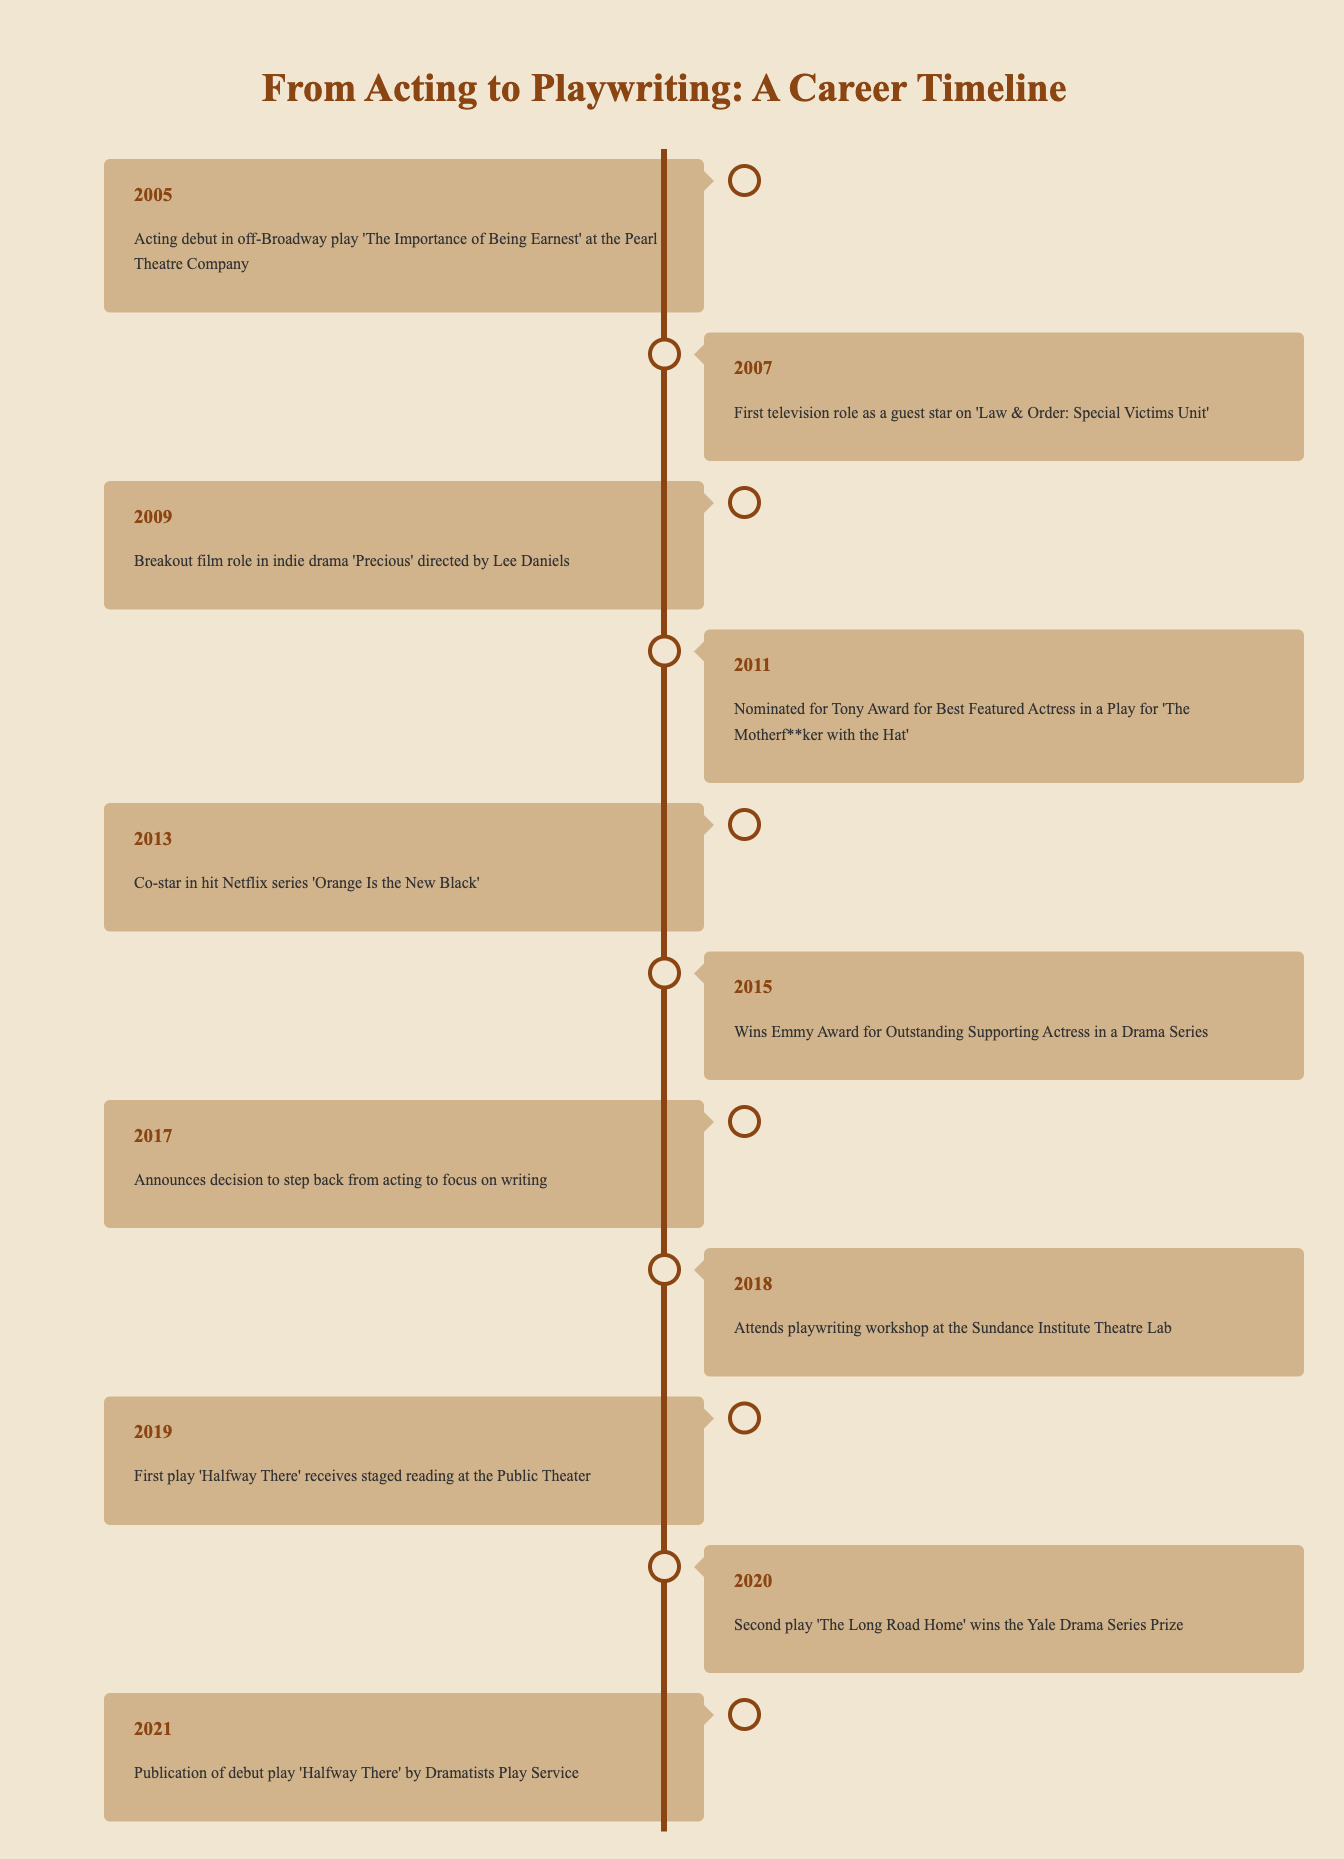What year did the acting debut occur? The acting debut is mentioned in the first row of the table, which states it happened in 2005.
Answer: 2005 In which event did the individual first appear on television? The second entry in the table indicates that the first television role was as a guest star on 'Law & Order: Special Victims Unit', which occurred in 2007.
Answer: 'Law & Order: Special Victims Unit' in 2007 What were the two awards or nominations received in the years leading up to the first play publication? Referring to the timeline, the individual was nominated for a Tony Award in 2011 and won an Emmy Award in 2015. Both events occurred prior to the play's publication in 2021.
Answer: Tony Award in 2011; Emmy Award in 2015 How many years passed between the acting debut and the first play reading? The acting debut was in 2005, and the first play staged reading occurred in 2019. If we subtract 2005 from 2019, we get 2019 - 2005 = 14 years.
Answer: 14 years Did the individual attend a playwriting workshop before publishing their first play? By examining the table, the individual attended a playwriting workshop in 2018, which is a year before the play was published in 2021, confirming the statement is true.
Answer: Yes What was the individual’s breakout film role and in what year did it occur? The table lists the breakout film role in indie drama 'Precious' occurred in 2009. This information is directly stated in the third entry.
Answer: 'Precious' in 2009 Was there a significant gap between deciding to step back from acting and the first play receiving a reading? According to the entries, the decision to step back from acting was made in 2017 and the first play received a reading in 2019. This creates a gap of 2 years, which is not particularly long.
Answer: No, the gap was 2 years How many plays mentioned were published before 2021? In the timeline, before the publication in 2021, the first play 'Halfway There' received a staged reading in 2019, and the second play 'The Long Road Home' was mentioned in 2020. Thus, there are 2 plays mentioned.
Answer: 2 plays 